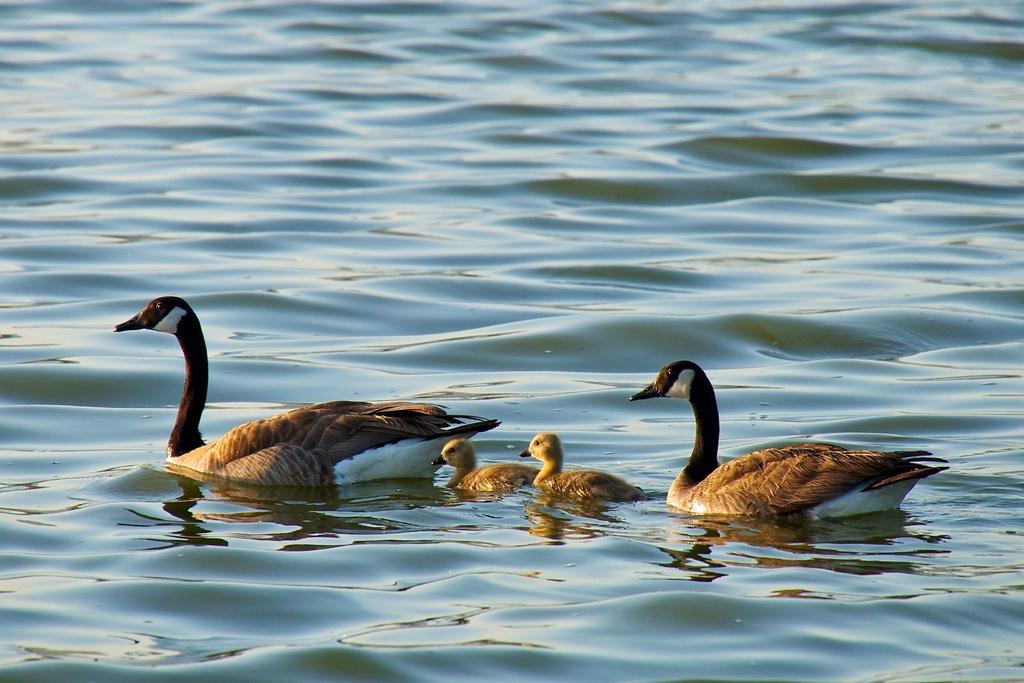Can you describe this image briefly? In this image we can see some ducks in a water body. 